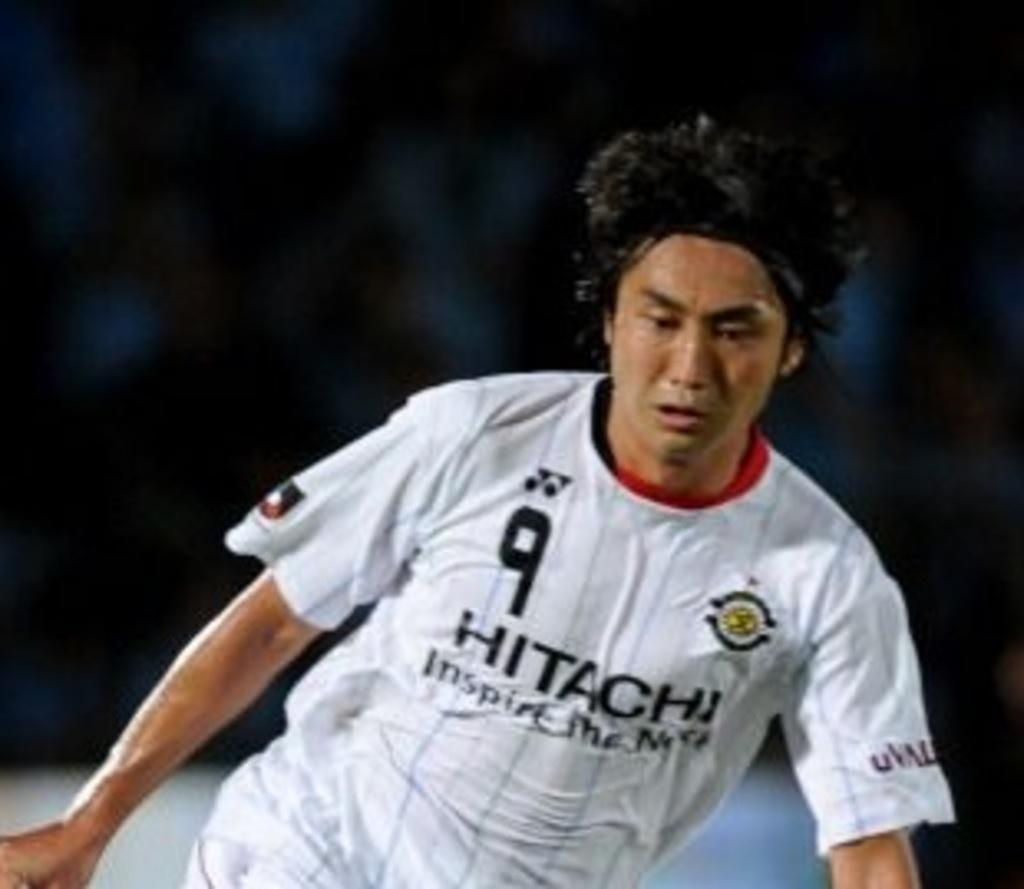<image>
Write a terse but informative summary of the picture. a man wears a white Hitachi 9 jersey on a field 